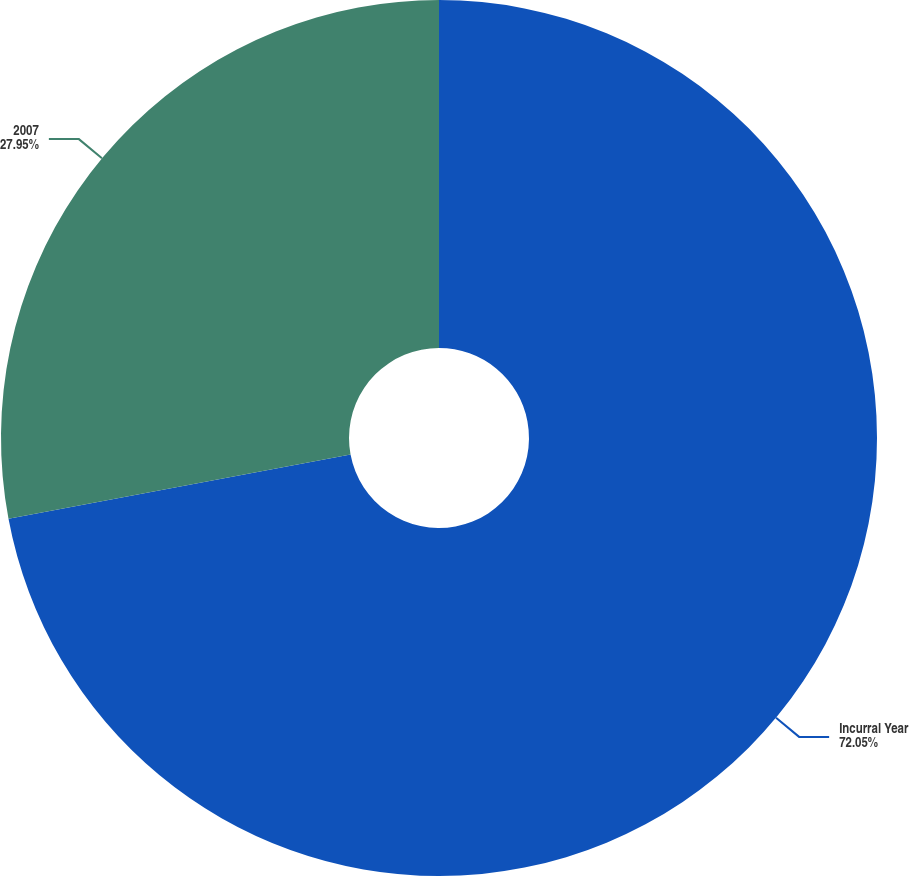Convert chart to OTSL. <chart><loc_0><loc_0><loc_500><loc_500><pie_chart><fcel>Incurral Year<fcel>2007<nl><fcel>72.05%<fcel>27.95%<nl></chart> 